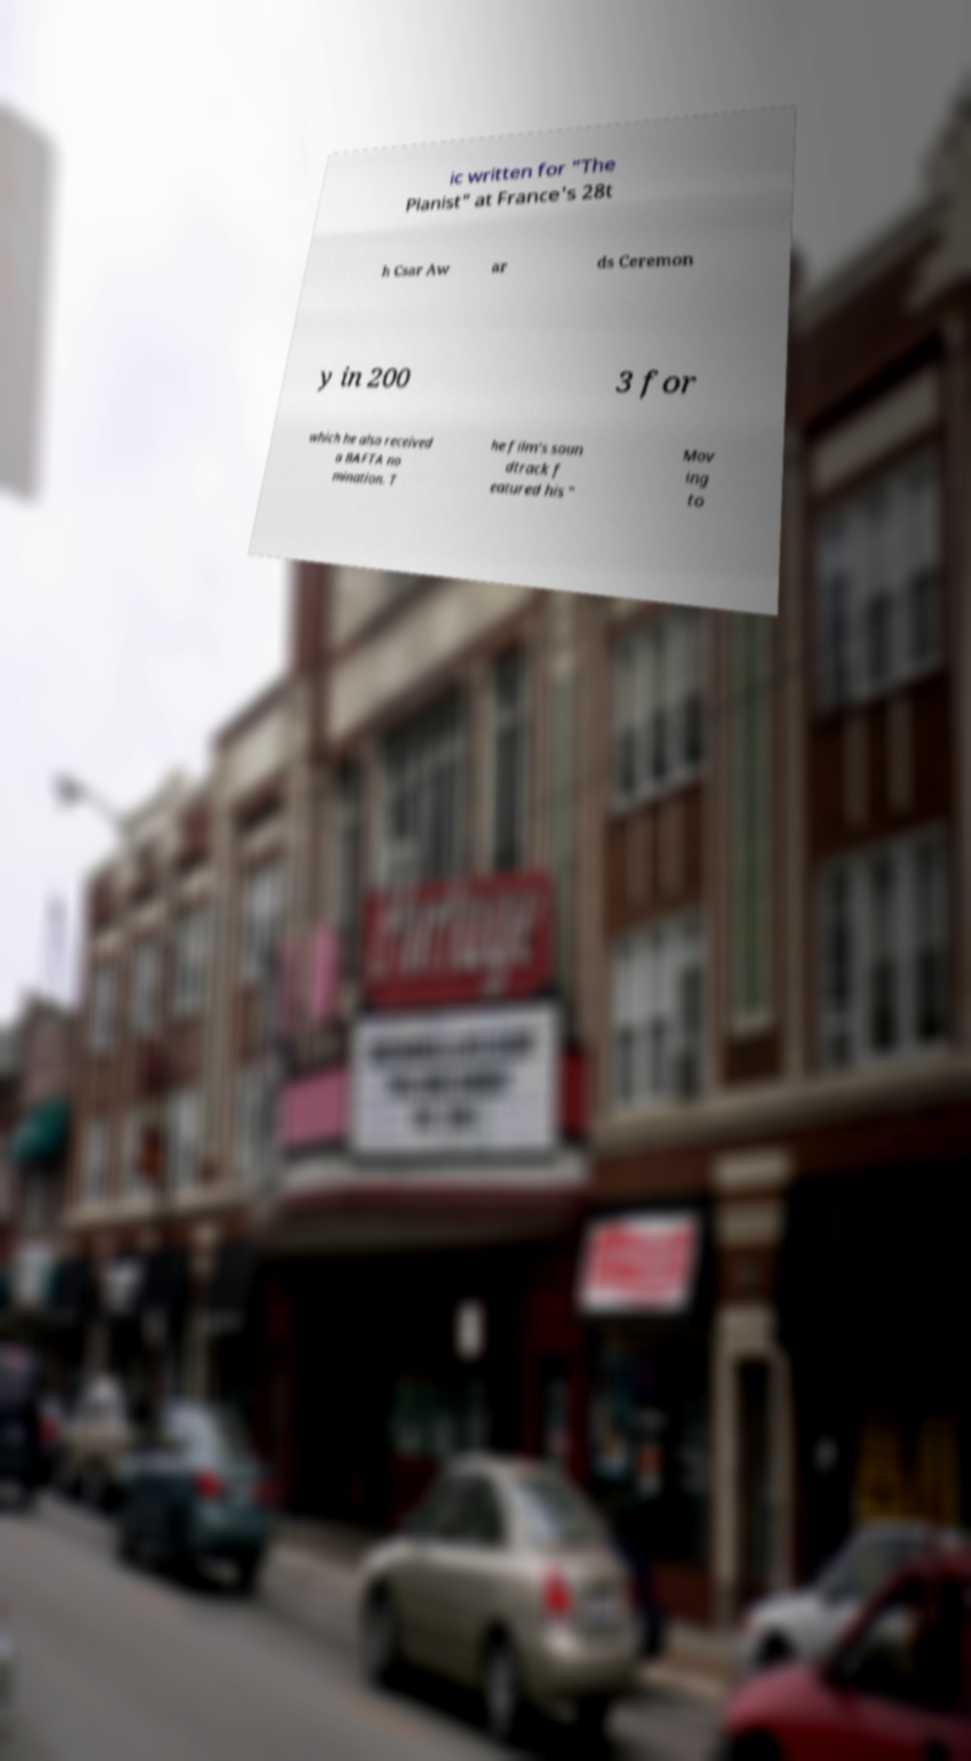Could you assist in decoding the text presented in this image and type it out clearly? ic written for "The Pianist" at France's 28t h Csar Aw ar ds Ceremon y in 200 3 for which he also received a BAFTA no mination. T he film's soun dtrack f eatured his " Mov ing to 